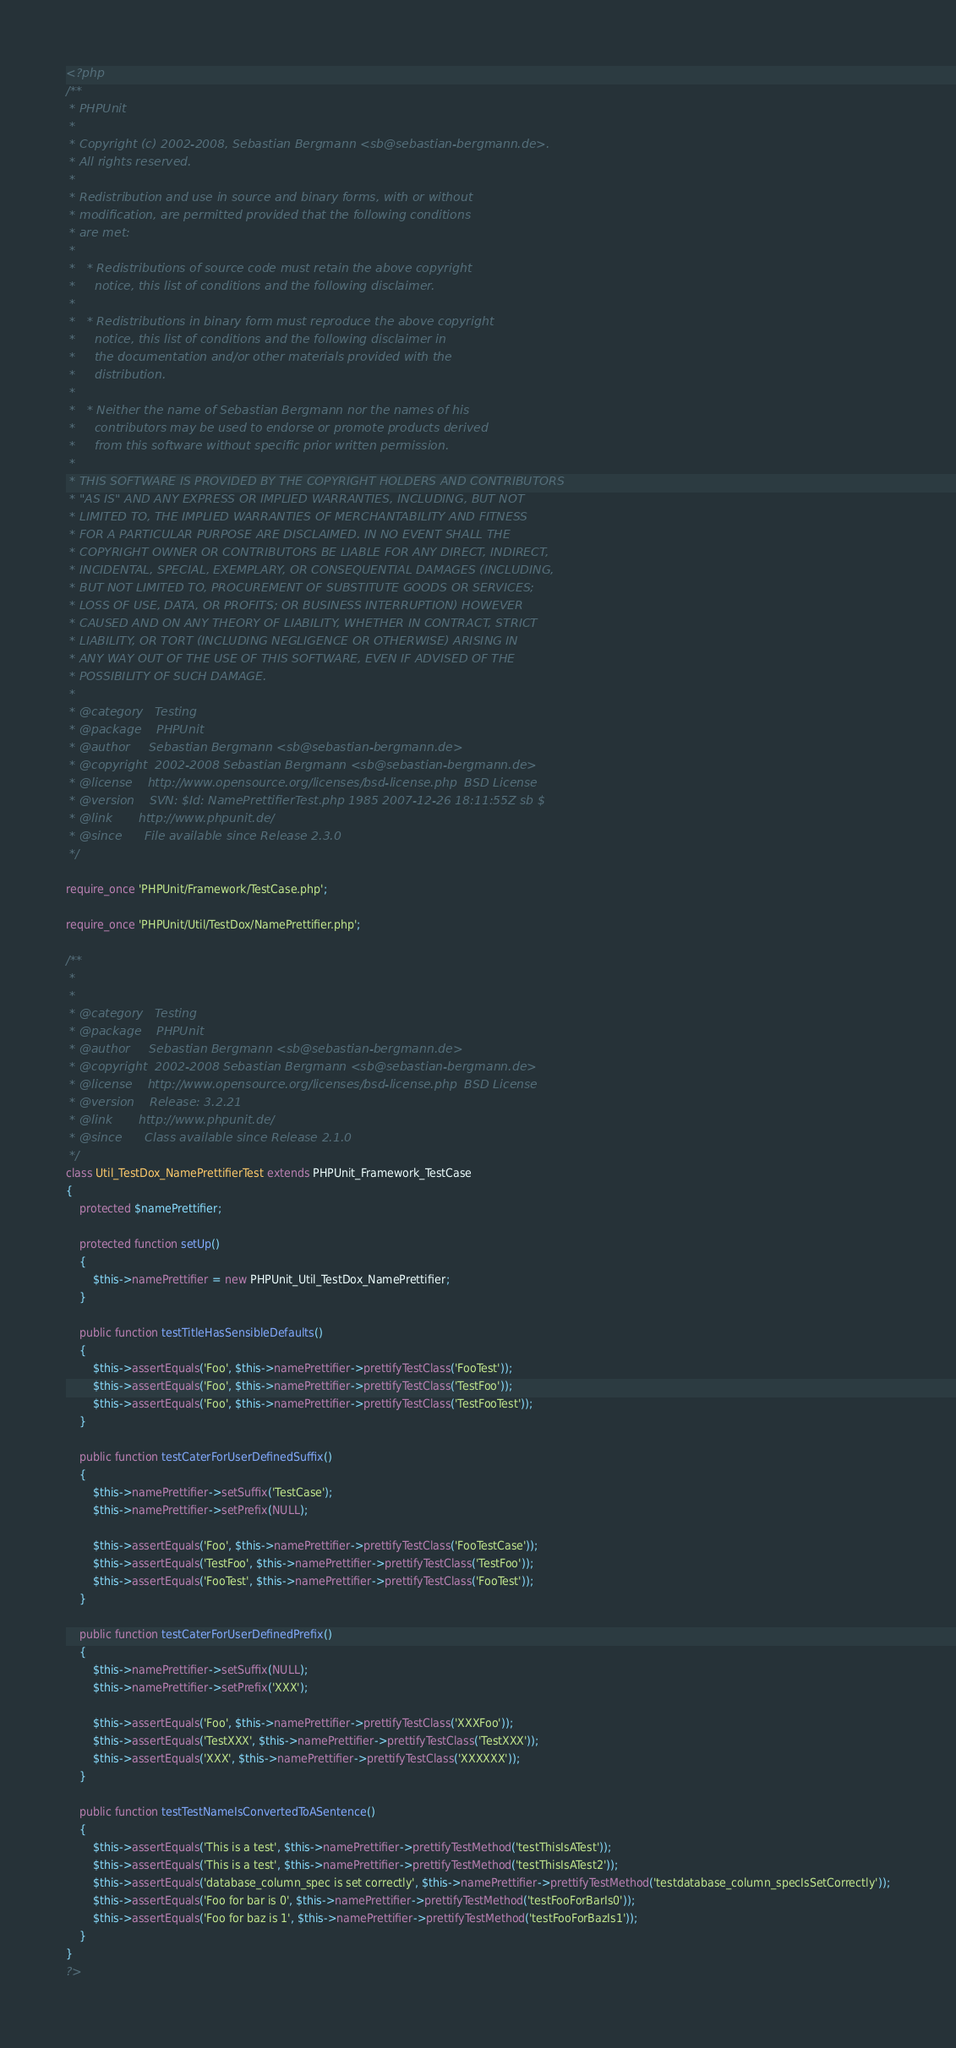<code> <loc_0><loc_0><loc_500><loc_500><_PHP_><?php
/**
 * PHPUnit
 *
 * Copyright (c) 2002-2008, Sebastian Bergmann <sb@sebastian-bergmann.de>.
 * All rights reserved.
 *
 * Redistribution and use in source and binary forms, with or without
 * modification, are permitted provided that the following conditions
 * are met:
 *
 *   * Redistributions of source code must retain the above copyright
 *     notice, this list of conditions and the following disclaimer.
 *
 *   * Redistributions in binary form must reproduce the above copyright
 *     notice, this list of conditions and the following disclaimer in
 *     the documentation and/or other materials provided with the
 *     distribution.
 *
 *   * Neither the name of Sebastian Bergmann nor the names of his
 *     contributors may be used to endorse or promote products derived
 *     from this software without specific prior written permission.
 *
 * THIS SOFTWARE IS PROVIDED BY THE COPYRIGHT HOLDERS AND CONTRIBUTORS
 * "AS IS" AND ANY EXPRESS OR IMPLIED WARRANTIES, INCLUDING, BUT NOT
 * LIMITED TO, THE IMPLIED WARRANTIES OF MERCHANTABILITY AND FITNESS
 * FOR A PARTICULAR PURPOSE ARE DISCLAIMED. IN NO EVENT SHALL THE
 * COPYRIGHT OWNER OR CONTRIBUTORS BE LIABLE FOR ANY DIRECT, INDIRECT,
 * INCIDENTAL, SPECIAL, EXEMPLARY, OR CONSEQUENTIAL DAMAGES (INCLUDING,
 * BUT NOT LIMITED TO, PROCUREMENT OF SUBSTITUTE GOODS OR SERVICES;
 * LOSS OF USE, DATA, OR PROFITS; OR BUSINESS INTERRUPTION) HOWEVER
 * CAUSED AND ON ANY THEORY OF LIABILITY, WHETHER IN CONTRACT, STRICT
 * LIABILITY, OR TORT (INCLUDING NEGLIGENCE OR OTHERWISE) ARISING IN
 * ANY WAY OUT OF THE USE OF THIS SOFTWARE, EVEN IF ADVISED OF THE
 * POSSIBILITY OF SUCH DAMAGE.
 *
 * @category   Testing
 * @package    PHPUnit
 * @author     Sebastian Bergmann <sb@sebastian-bergmann.de>
 * @copyright  2002-2008 Sebastian Bergmann <sb@sebastian-bergmann.de>
 * @license    http://www.opensource.org/licenses/bsd-license.php  BSD License
 * @version    SVN: $Id: NamePrettifierTest.php 1985 2007-12-26 18:11:55Z sb $
 * @link       http://www.phpunit.de/
 * @since      File available since Release 2.3.0
 */

require_once 'PHPUnit/Framework/TestCase.php';

require_once 'PHPUnit/Util/TestDox/NamePrettifier.php';

/**
 *
 *
 * @category   Testing
 * @package    PHPUnit
 * @author     Sebastian Bergmann <sb@sebastian-bergmann.de>
 * @copyright  2002-2008 Sebastian Bergmann <sb@sebastian-bergmann.de>
 * @license    http://www.opensource.org/licenses/bsd-license.php  BSD License
 * @version    Release: 3.2.21
 * @link       http://www.phpunit.de/
 * @since      Class available since Release 2.1.0
 */
class Util_TestDox_NamePrettifierTest extends PHPUnit_Framework_TestCase
{
    protected $namePrettifier;

    protected function setUp()
    {
        $this->namePrettifier = new PHPUnit_Util_TestDox_NamePrettifier;
    }

    public function testTitleHasSensibleDefaults()
    {
        $this->assertEquals('Foo', $this->namePrettifier->prettifyTestClass('FooTest'));
        $this->assertEquals('Foo', $this->namePrettifier->prettifyTestClass('TestFoo'));
        $this->assertEquals('Foo', $this->namePrettifier->prettifyTestClass('TestFooTest'));
    }

    public function testCaterForUserDefinedSuffix()
    {
        $this->namePrettifier->setSuffix('TestCase');
        $this->namePrettifier->setPrefix(NULL);

        $this->assertEquals('Foo', $this->namePrettifier->prettifyTestClass('FooTestCase'));
        $this->assertEquals('TestFoo', $this->namePrettifier->prettifyTestClass('TestFoo'));
        $this->assertEquals('FooTest', $this->namePrettifier->prettifyTestClass('FooTest'));
    }

    public function testCaterForUserDefinedPrefix()
    {
        $this->namePrettifier->setSuffix(NULL);
        $this->namePrettifier->setPrefix('XXX');

        $this->assertEquals('Foo', $this->namePrettifier->prettifyTestClass('XXXFoo'));
        $this->assertEquals('TestXXX', $this->namePrettifier->prettifyTestClass('TestXXX'));
        $this->assertEquals('XXX', $this->namePrettifier->prettifyTestClass('XXXXXX'));
    }

    public function testTestNameIsConvertedToASentence()
    {
        $this->assertEquals('This is a test', $this->namePrettifier->prettifyTestMethod('testThisIsATest'));
        $this->assertEquals('This is a test', $this->namePrettifier->prettifyTestMethod('testThisIsATest2'));
        $this->assertEquals('database_column_spec is set correctly', $this->namePrettifier->prettifyTestMethod('testdatabase_column_specIsSetCorrectly'));
        $this->assertEquals('Foo for bar is 0', $this->namePrettifier->prettifyTestMethod('testFooForBarIs0'));
        $this->assertEquals('Foo for baz is 1', $this->namePrettifier->prettifyTestMethod('testFooForBazIs1'));
    }
}
?>
</code> 